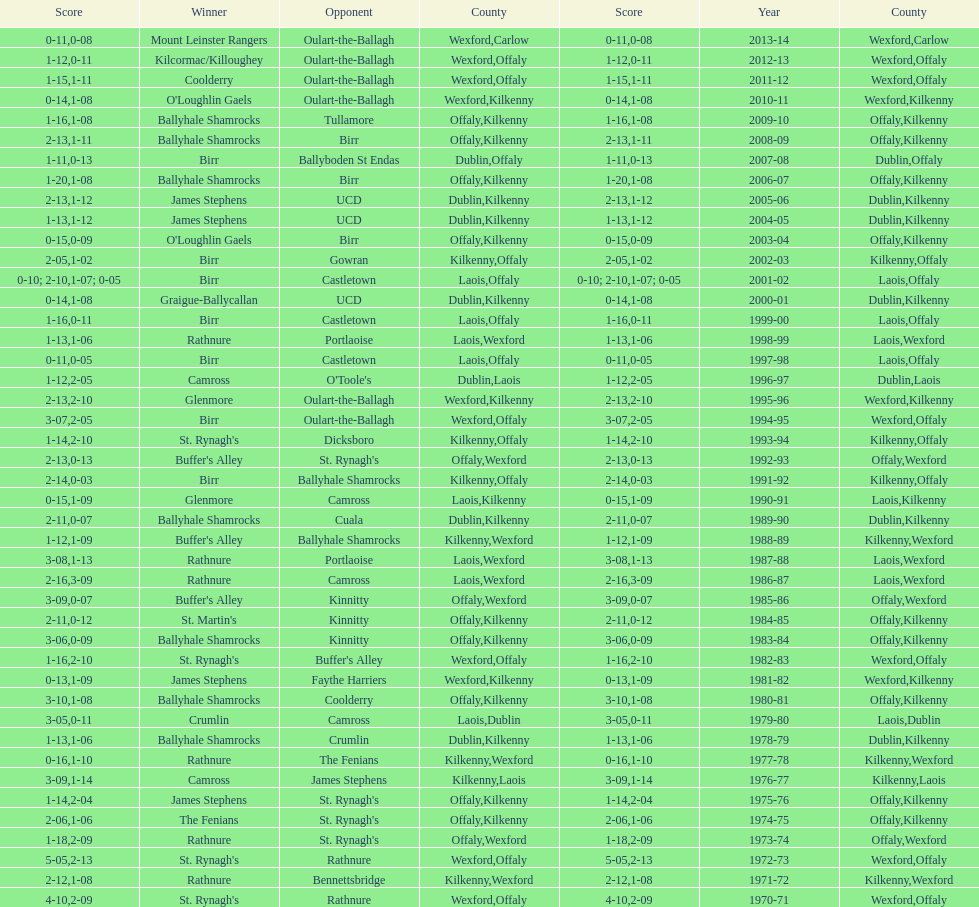Which team won the leinster senior club hurling championships previous to the last time birr won? Ballyhale Shamrocks. 